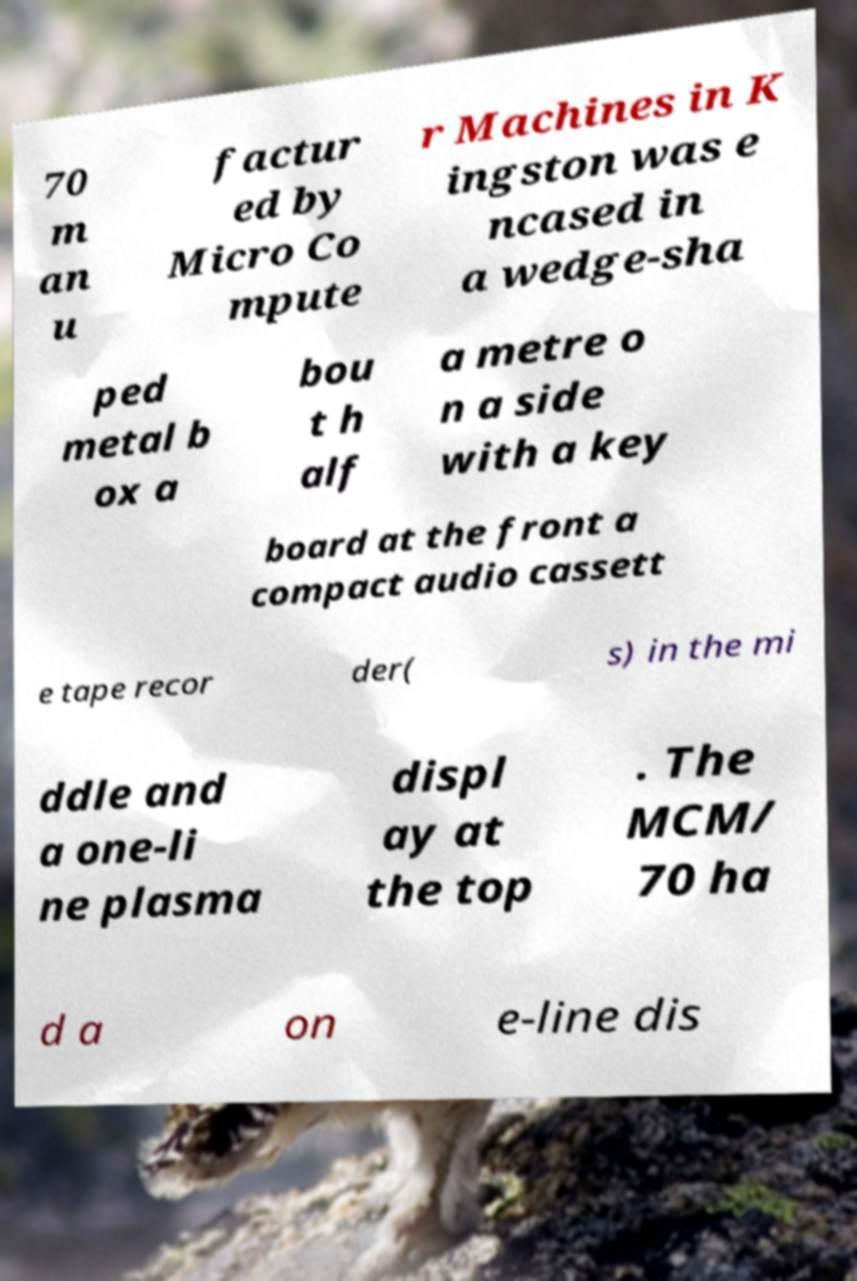For documentation purposes, I need the text within this image transcribed. Could you provide that? 70 m an u factur ed by Micro Co mpute r Machines in K ingston was e ncased in a wedge-sha ped metal b ox a bou t h alf a metre o n a side with a key board at the front a compact audio cassett e tape recor der( s) in the mi ddle and a one-li ne plasma displ ay at the top . The MCM/ 70 ha d a on e-line dis 